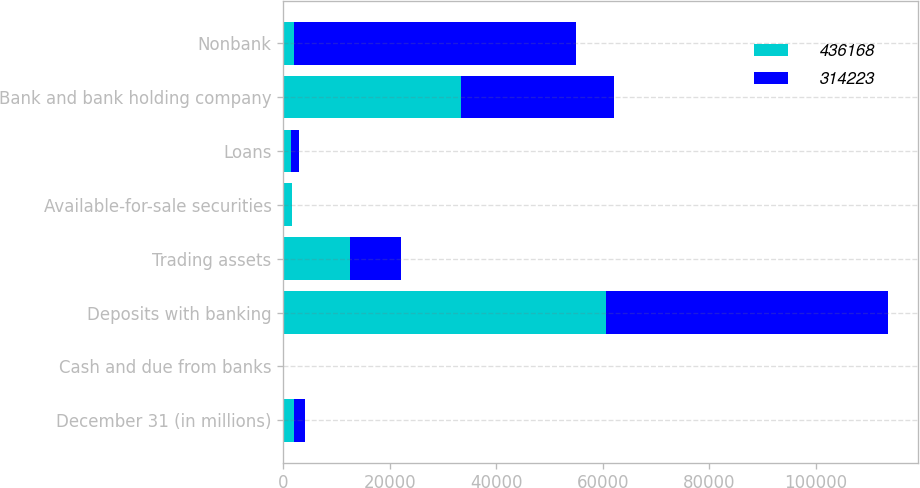Convert chart. <chart><loc_0><loc_0><loc_500><loc_500><stacked_bar_chart><ecel><fcel>December 31 (in millions)<fcel>Cash and due from banks<fcel>Deposits with banking<fcel>Trading assets<fcel>Available-for-sale securities<fcel>Loans<fcel>Bank and bank holding company<fcel>Nonbank<nl><fcel>436168<fcel>2008<fcel>35<fcel>60551<fcel>12487<fcel>1587<fcel>1525<fcel>33293<fcel>2008<nl><fcel>314223<fcel>2007<fcel>110<fcel>52972<fcel>9563<fcel>43<fcel>1423<fcel>28705<fcel>52895<nl></chart> 